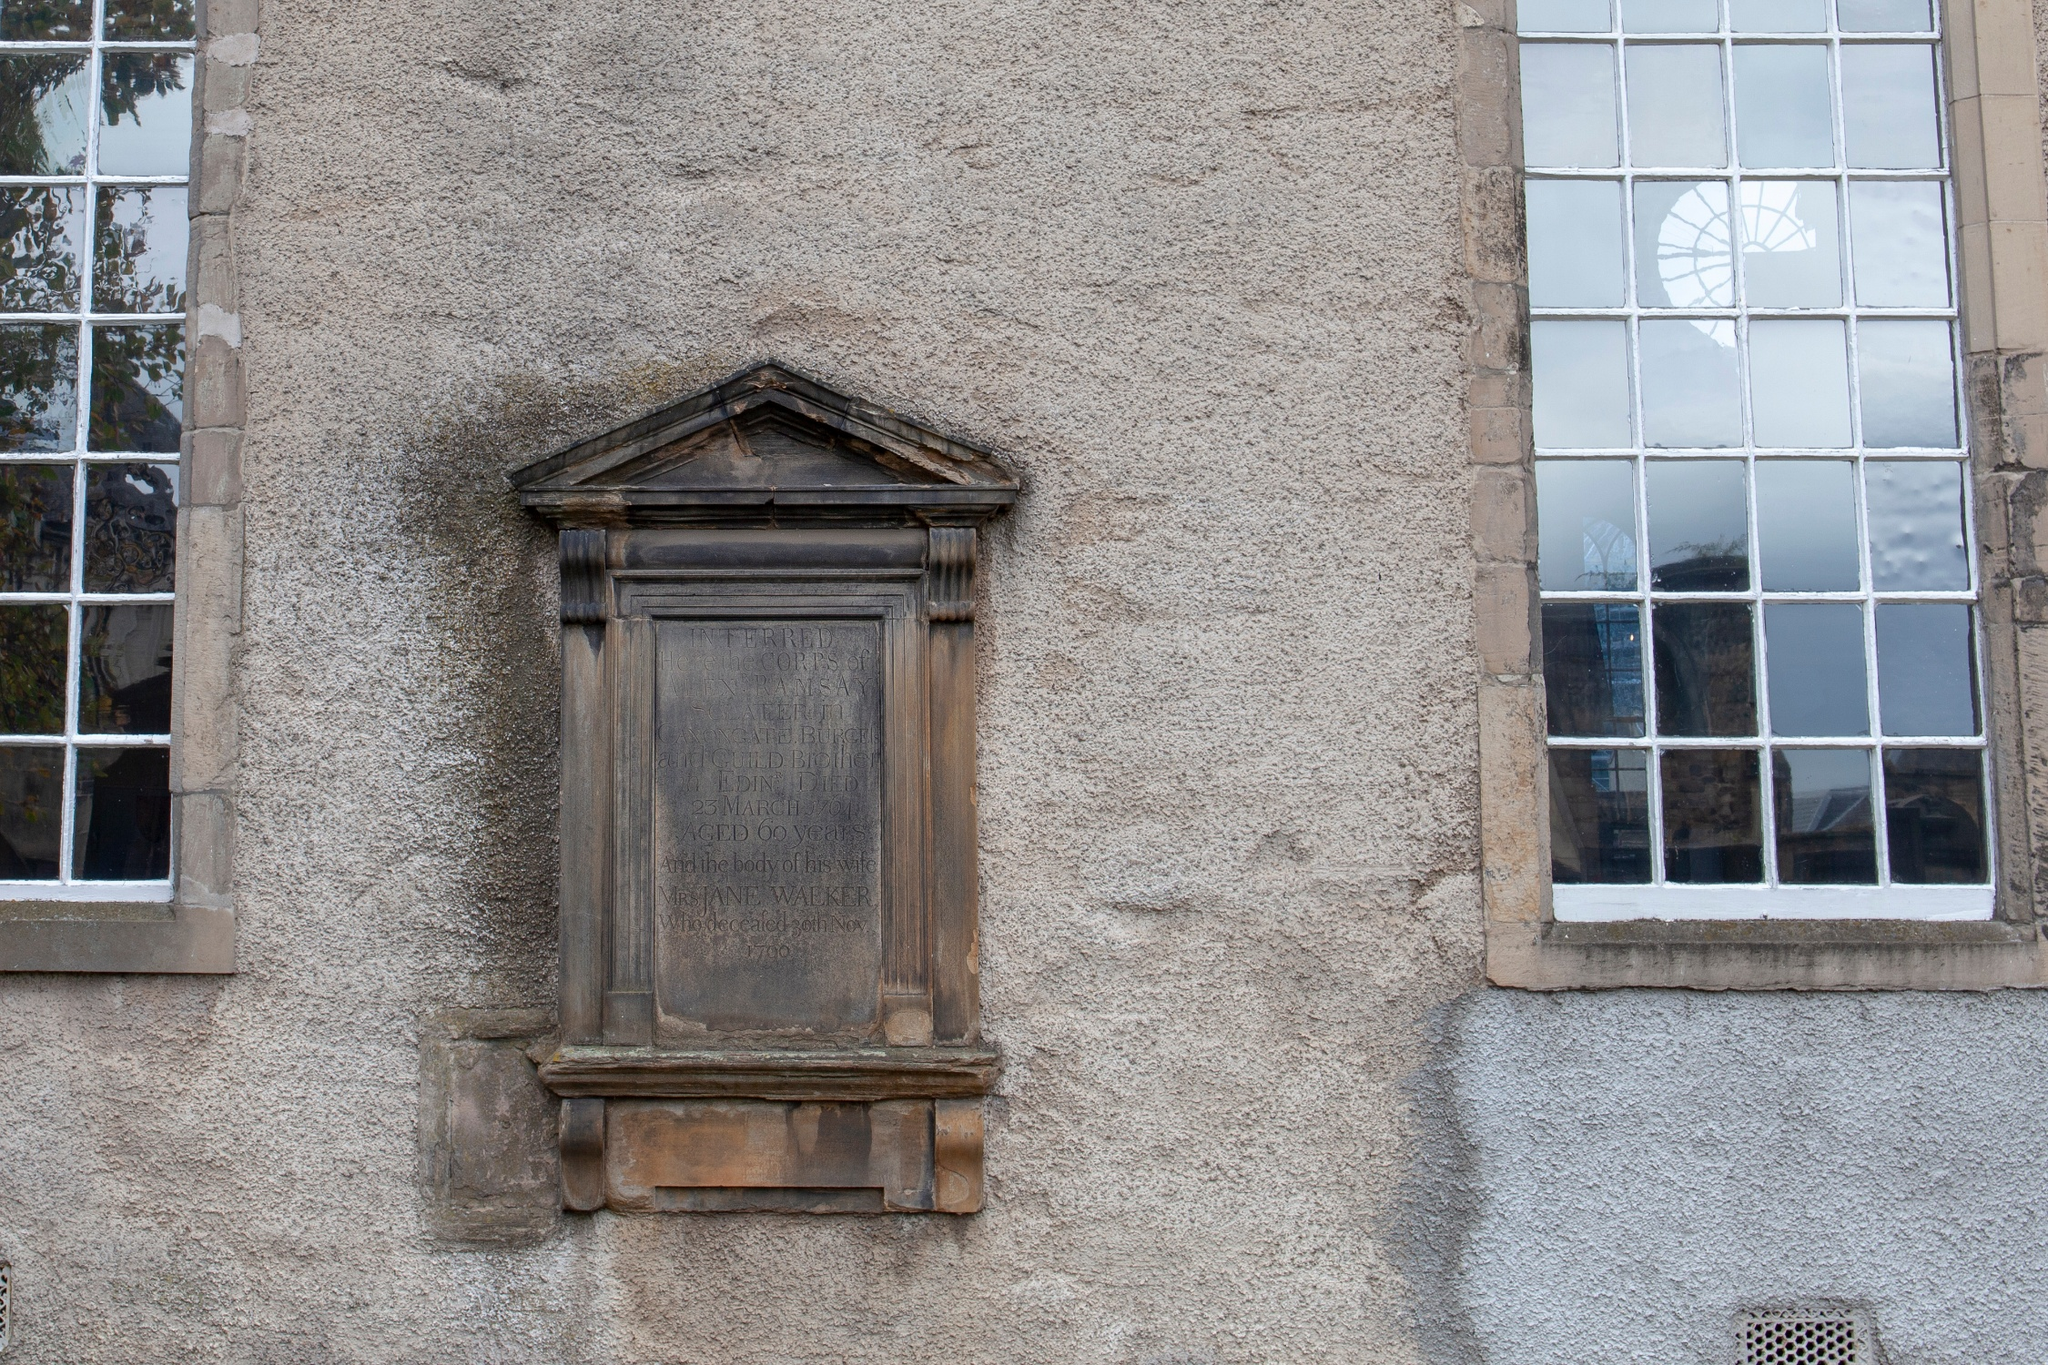How do the architectural features reflect the age or history of this building? The building’s architectural features suggest a long history with multiple influences. The arched window aligns with older, perhaps even medieval architectural styles typical in European contexts, indicating the building’s older sections. The rectangular window, being simpler and less ornate, could be indicative of a later period or a time when functionality was prioritized over aesthetics. These features, combined with the worn facade, suggest modifications over centuries, reflecting changes in architectural trends and possibly the building’s use over time. 